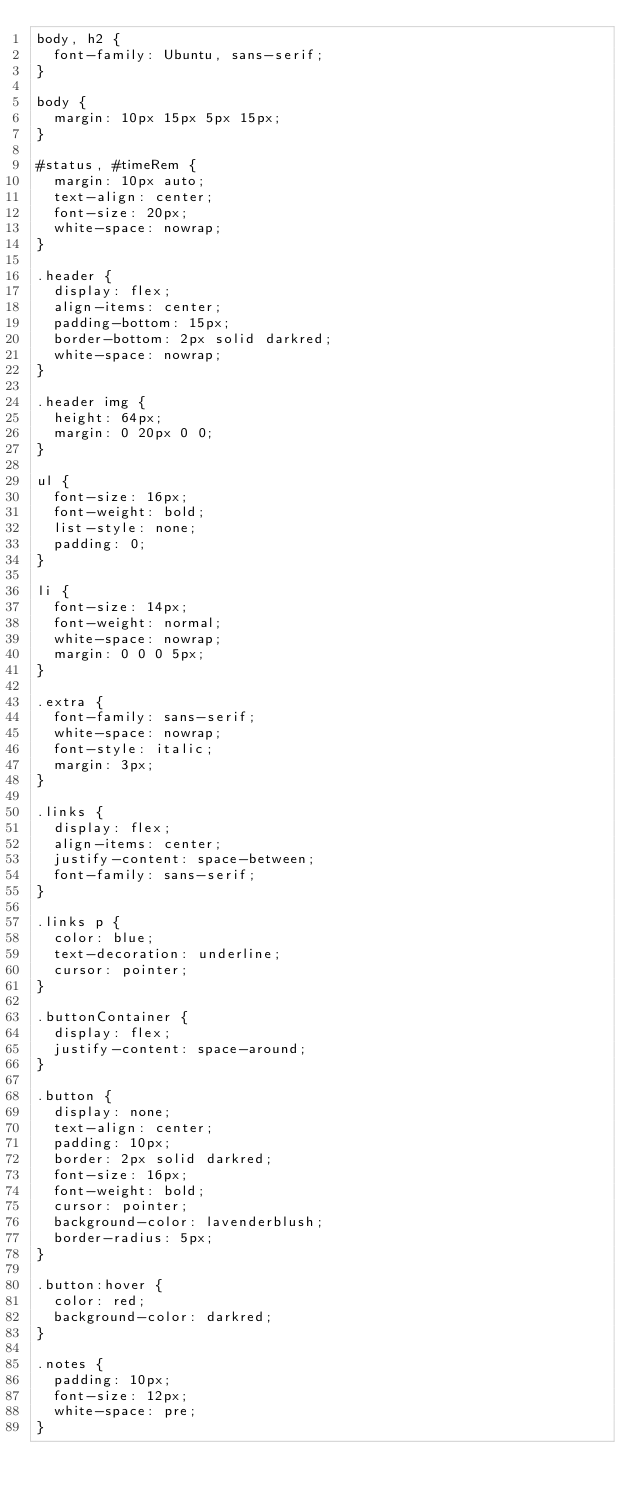<code> <loc_0><loc_0><loc_500><loc_500><_CSS_>body, h2 {
  font-family: Ubuntu, sans-serif;
}

body {
  margin: 10px 15px 5px 15px;
}

#status, #timeRem {
  margin: 10px auto;
  text-align: center;
  font-size: 20px;
  white-space: nowrap;
}

.header {
  display: flex;
  align-items: center;
  padding-bottom: 15px;
  border-bottom: 2px solid darkred;
  white-space: nowrap;
}

.header img {
  height: 64px;
  margin: 0 20px 0 0;
}

ul {
  font-size: 16px;
  font-weight: bold;
  list-style: none;
  padding: 0;
}

li {
  font-size: 14px;
  font-weight: normal;
  white-space: nowrap;
  margin: 0 0 0 5px;
}

.extra {
  font-family: sans-serif;
  white-space: nowrap;
  font-style: italic;
  margin: 3px;
}

.links {
  display: flex;
  align-items: center;
  justify-content: space-between;
  font-family: sans-serif;
}

.links p {
  color: blue;
  text-decoration: underline;
  cursor: pointer;
}

.buttonContainer {
  display: flex;
  justify-content: space-around;
}

.button {
  display: none;
  text-align: center;
  padding: 10px;
  border: 2px solid darkred;
  font-size: 16px;
  font-weight: bold;
  cursor: pointer;
  background-color: lavenderblush;
  border-radius: 5px;
}

.button:hover {
  color: red;
  background-color: darkred;
}

.notes {
  padding: 10px;
  font-size: 12px;
  white-space: pre;
}
</code> 